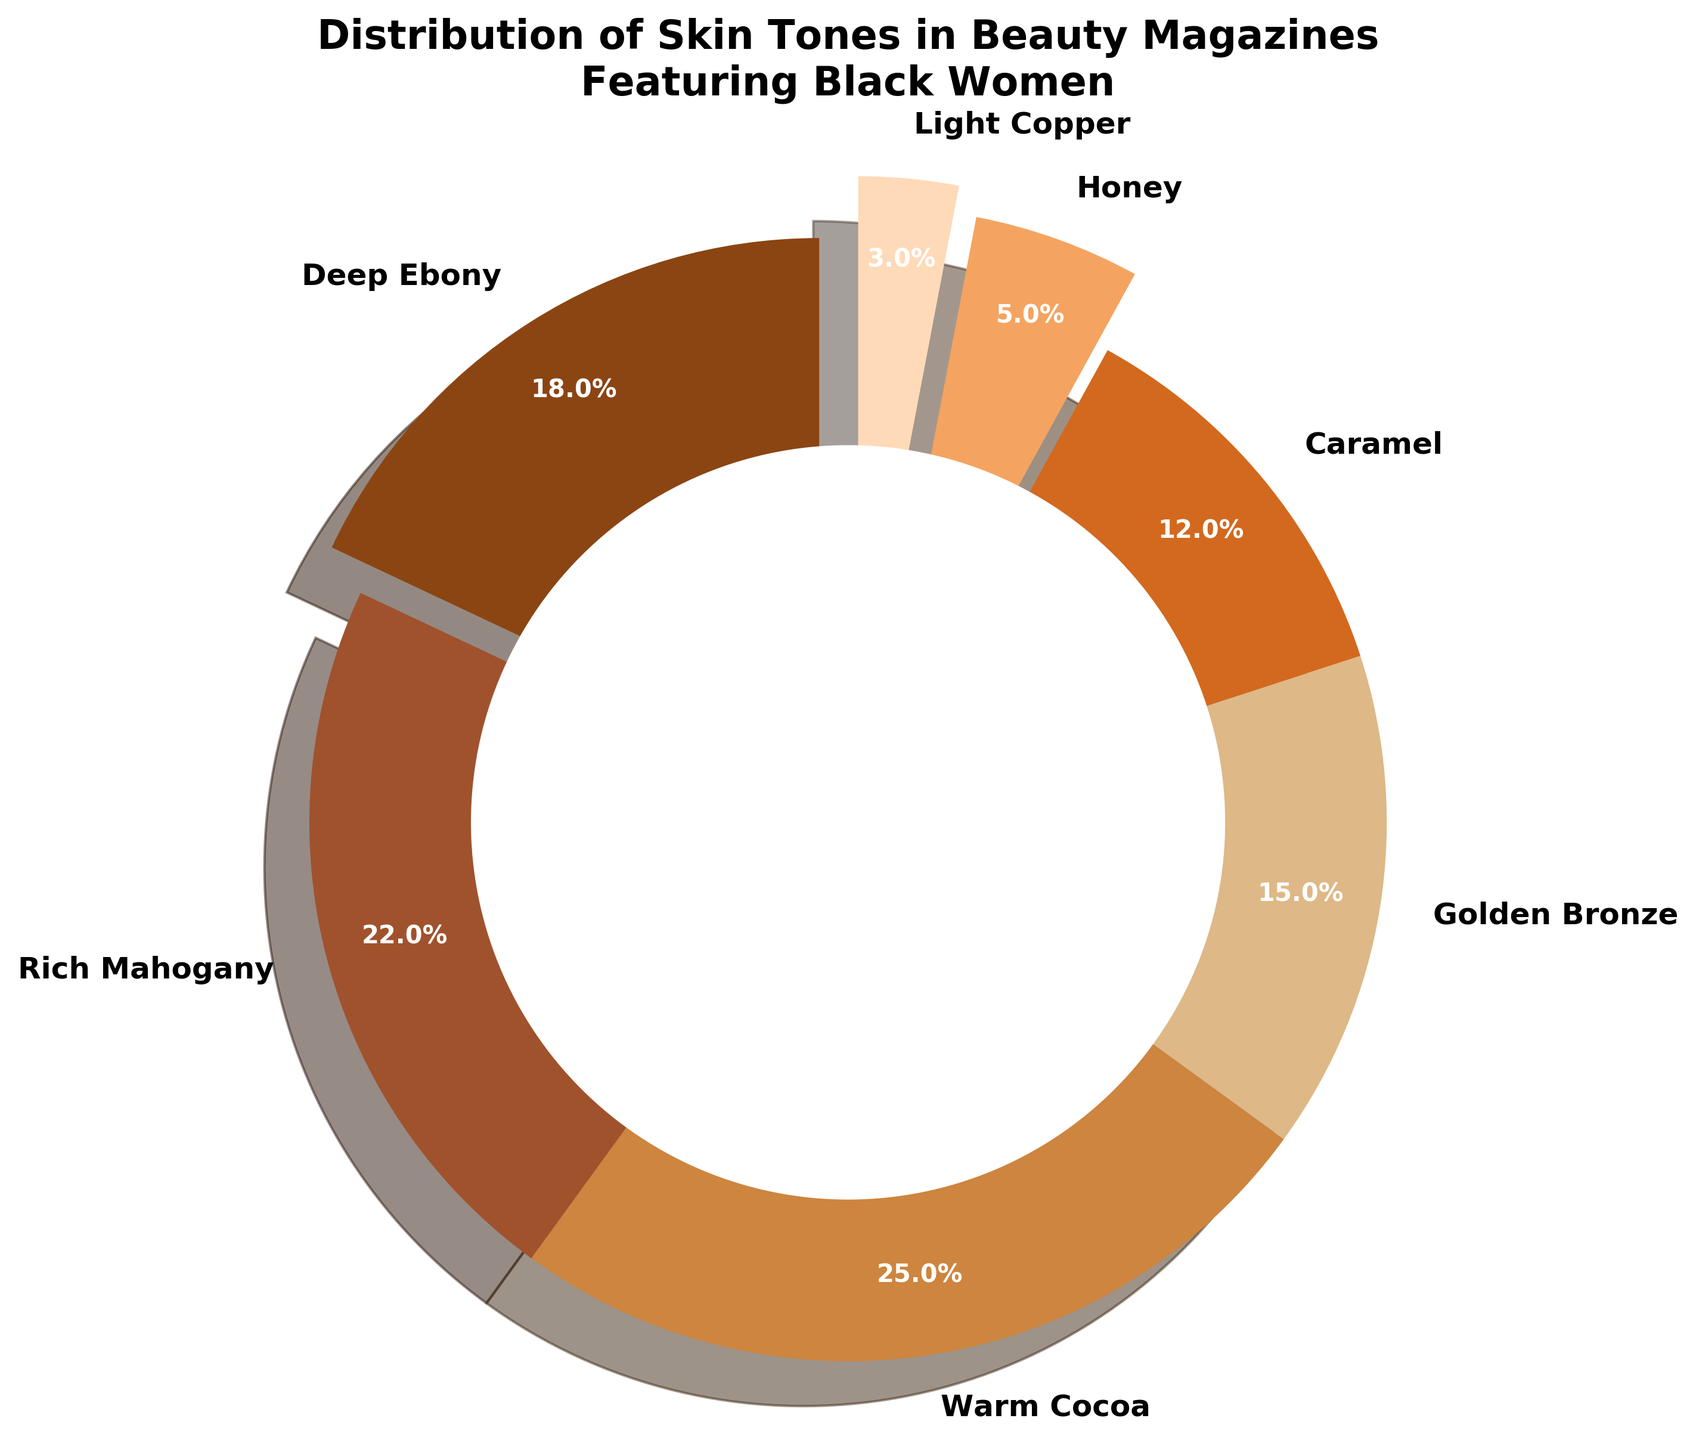What is the percentage of magazines that feature Warm Cocoa skin tone? Warm Cocoa is one of the segments in the pie chart. By looking at the labels, we see that Warm Cocoa represents 25% of the chart.
Answer: 25% Which skin tone is represented the least in beauty magazines? The smallest segment in the pie chart corresponds to Light Copper, with only 3% representation.
Answer: Light Copper What is the combined percentage of magazines featuring Rich Mahogany and Golden Bronze skin tones? Rich Mahogany represents 22% and Golden Bronze represents 15%. Adding these together, we get 22% + 15% = 37%.
Answer: 37% Which skin tone segment appears larger: Caramel or Honey? Comparing the two segments visually and by their labels, Caramel has 12%, while Honey has 5%. Hence, Caramel appears larger.
Answer: Caramel What is the difference in percentage between Deep Ebony and Light Copper? Deep Ebony has 18%, and Light Copper has 3%. The difference is 18% - 3% = 15%.
Answer: 15% What percentage of skin tones are represented by Caramel and Light Copper combined? The percentage for Caramel is 12% and for Light Copper is 3%. Combined, they account for 12% + 3% = 15%.
Answer: 15% Are there more magazines featuring Rich Mahogany or Golden Bronze? We compare the segments: Rich Mahogany has 22% and Golden Bronze has 15%. Therefore, there are more magazines featuring Rich Mahogany.
Answer: Rich Mahogany Which skin tone is represented in the largest percentage of magazines? The largest segment in the pie chart corresponds to Warm Cocoa, which represents 25%.
Answer: Warm Cocoa What proportion of magazines feature either Deep Ebony or Honey skin tones? Deep Ebony represents 18% and Honey represents 5%. So, together they represent 18% + 5% = 23%.
Answer: 23% What is the average percentage representation of Deep Ebony, Rich Mahogany, and Warm Cocoa? Sum the percentages: 18% (Deep Ebony) + 22% (Rich Mahogany) + 25% (Warm Cocoa) = 65%. Divide by 3: 65% / 3 = ~21.67%.
Answer: 21.67% 